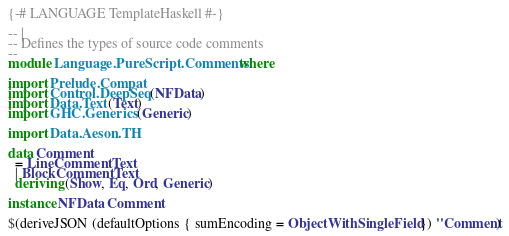Convert code to text. <code><loc_0><loc_0><loc_500><loc_500><_Haskell_>{-# LANGUAGE TemplateHaskell #-}

-- |
-- Defines the types of source code comments
--
module Language.PureScript.Comments where

import Prelude.Compat
import Control.DeepSeq (NFData)
import Data.Text (Text)
import GHC.Generics (Generic)

import Data.Aeson.TH

data Comment
  = LineComment Text
  | BlockComment Text
  deriving (Show, Eq, Ord, Generic)

instance NFData Comment

$(deriveJSON (defaultOptions { sumEncoding = ObjectWithSingleField }) ''Comment)
</code> 